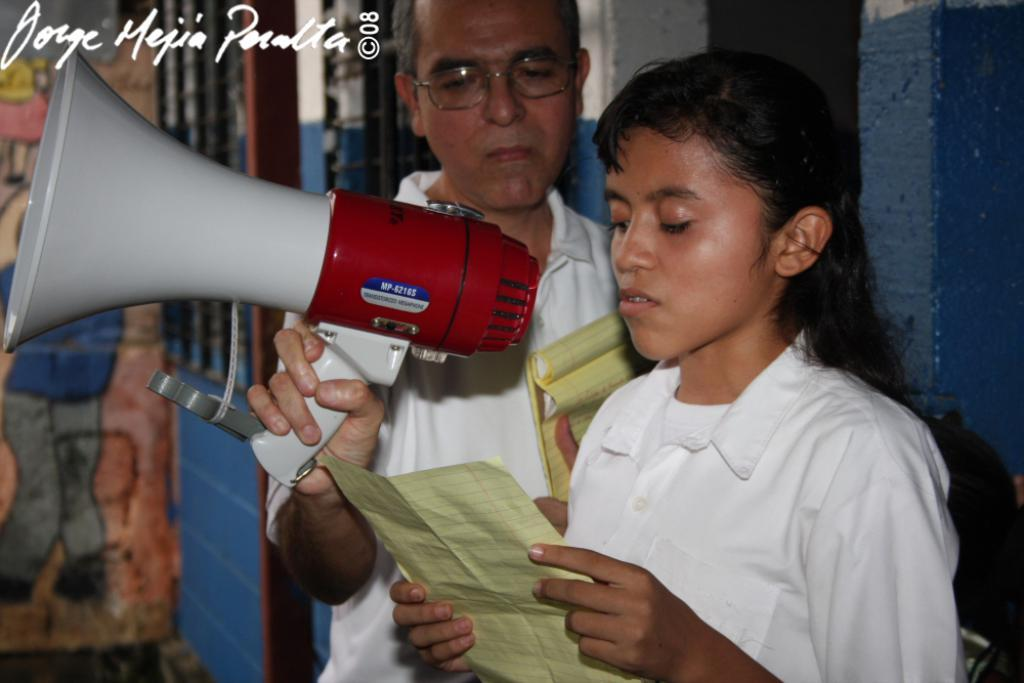How many people are present in the image? There are two people, a man and a woman, present in the image. What is the woman holding in the image? The woman is holding a paper. What is the woman doing with the paper? The woman is reading the paper. What is the man holding in the image? The man is holding a mic. What can be seen in the background of the image? There are walls and a window in the background of the image. What type of tin can be seen on the wing of the airplane in the image? There is no airplane or tin present in the image. How many accounts does the woman have in the image? There is no mention of accounts in the image. 